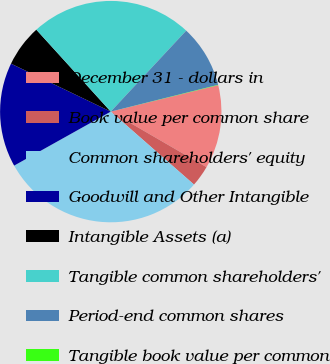<chart> <loc_0><loc_0><loc_500><loc_500><pie_chart><fcel>December 31 - dollars in<fcel>Book value per common share<fcel>Common shareholders' equity<fcel>Goodwill and Other Intangible<fcel>Intangible Assets (a)<fcel>Tangible common shareholders'<fcel>Period-end common shares<fcel>Tangible book value per common<nl><fcel>12.21%<fcel>3.09%<fcel>30.44%<fcel>15.25%<fcel>6.13%<fcel>23.68%<fcel>9.17%<fcel>0.05%<nl></chart> 